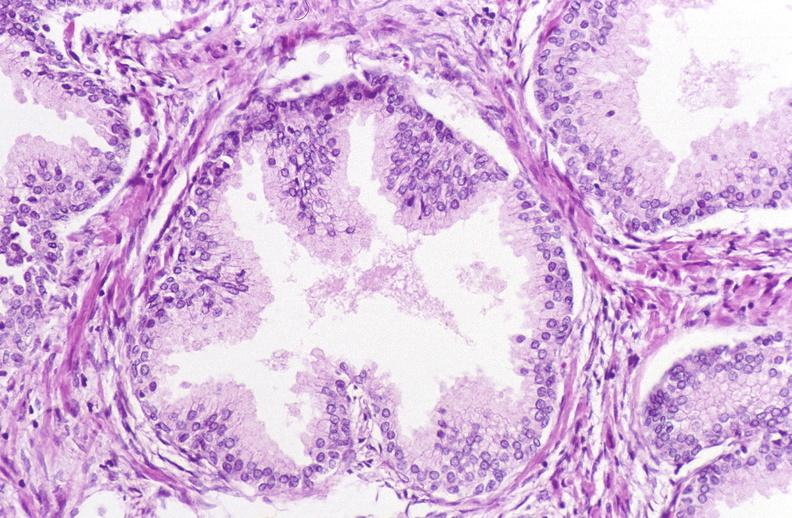does this image show prostate, benign prostatic hyperplasia?
Answer the question using a single word or phrase. Yes 